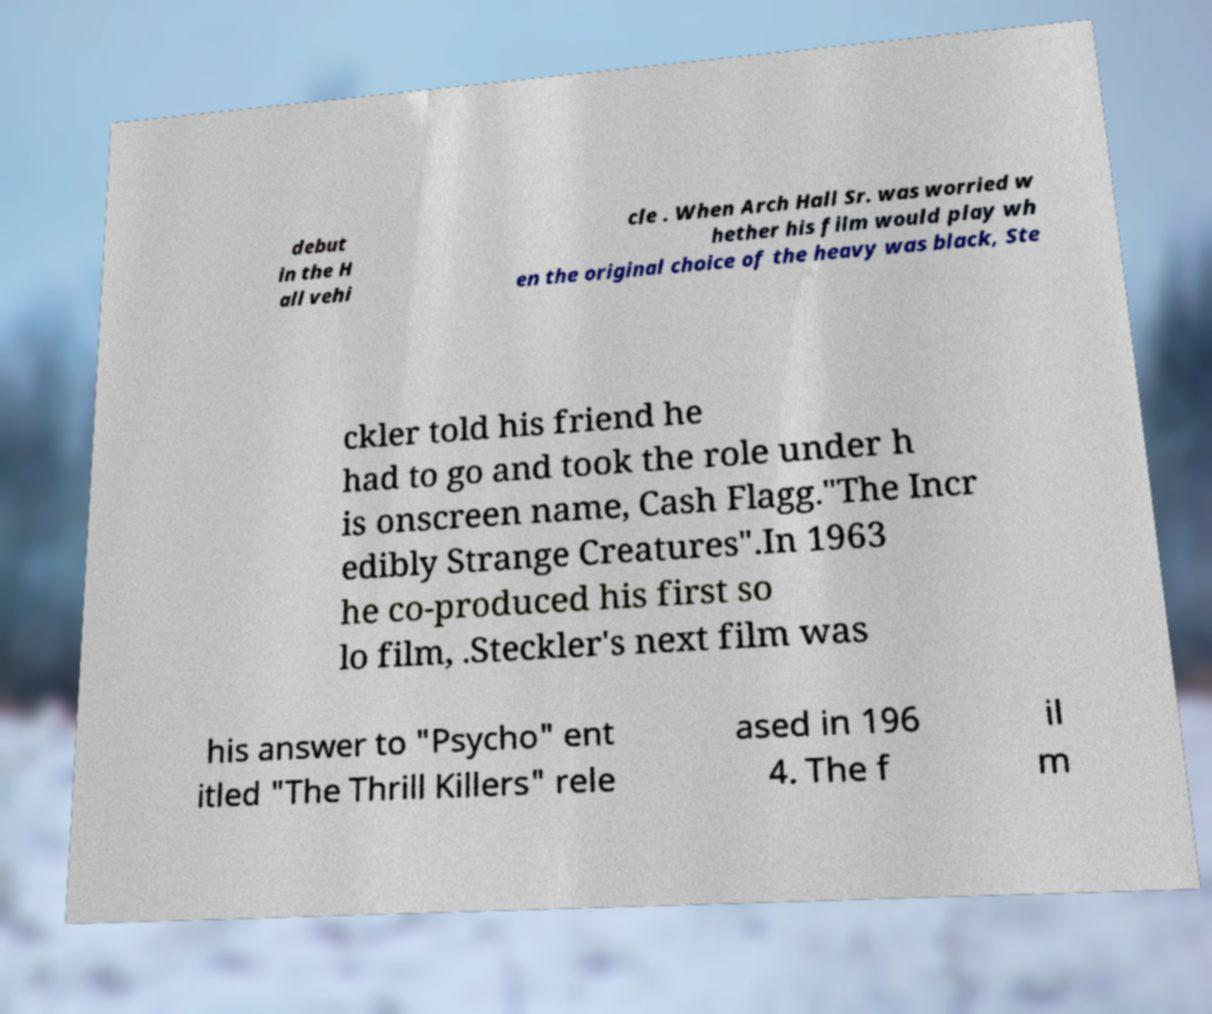Could you assist in decoding the text presented in this image and type it out clearly? debut in the H all vehi cle . When Arch Hall Sr. was worried w hether his film would play wh en the original choice of the heavy was black, Ste ckler told his friend he had to go and took the role under h is onscreen name, Cash Flagg."The Incr edibly Strange Creatures".In 1963 he co-produced his first so lo film, .Steckler's next film was his answer to "Psycho" ent itled "The Thrill Killers" rele ased in 196 4. The f il m 